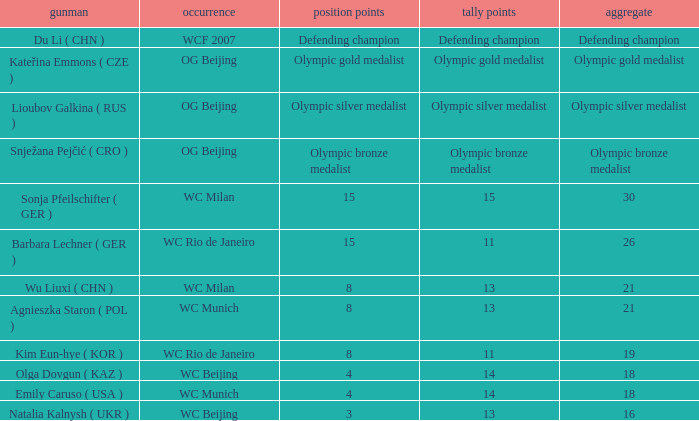Which event had a total of defending champion? WCF 2007. 